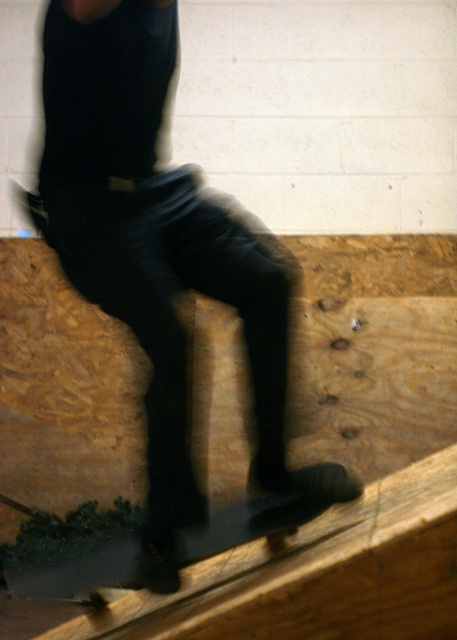Describe the objects in this image and their specific colors. I can see people in darkgray, black, maroon, and gray tones and skateboard in darkgray, black, olive, and gray tones in this image. 